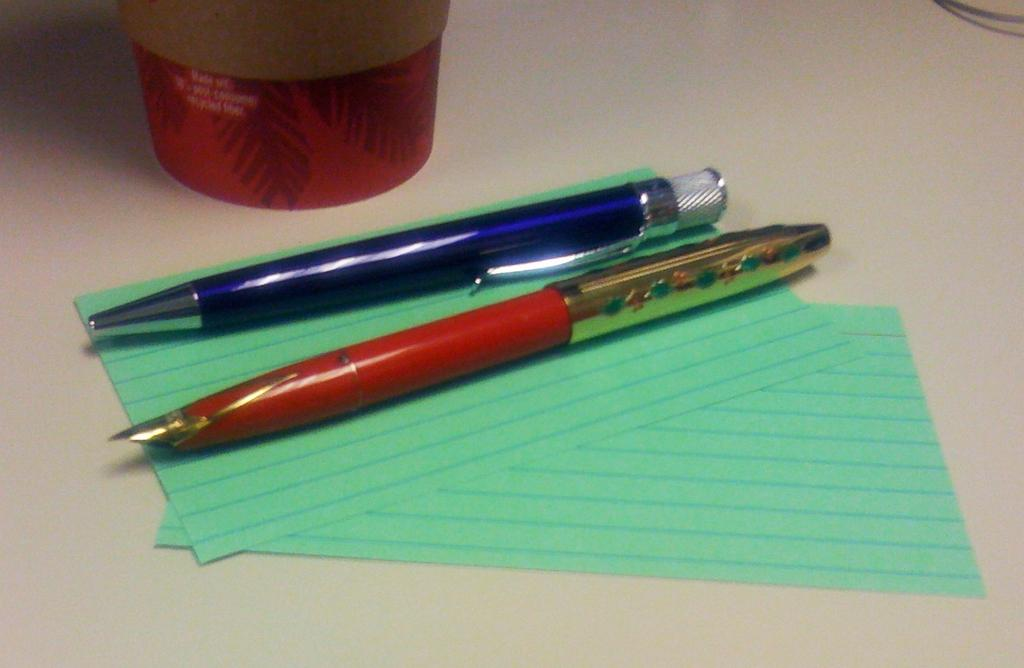What writing instruments are present in the image? There are two different types of pens in the image. What else can be seen on the table besides the pens? There are two papers and a box on the table. Is there any other object visible on the table? Yes, there is a wire in the image. Where are all these objects located? All of these objects are on a table. What type of weather can be seen in the image? There is no weather mentioned or depicted in the image; it only shows objects on a table. Are there any bears visible in the image? No, there are no bears present in the image. 